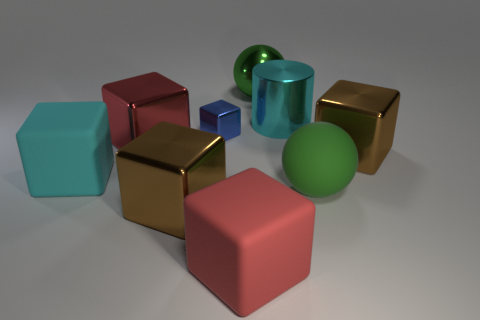There is a ball that is the same material as the large cyan cylinder; what is its color?
Ensure brevity in your answer.  Green. There is a cyan cube; does it have the same size as the red matte cube in front of the large cylinder?
Make the answer very short. Yes. The tiny thing has what shape?
Ensure brevity in your answer.  Cube. How many other things have the same color as the tiny thing?
Keep it short and to the point. 0. There is a tiny shiny object that is the same shape as the cyan matte thing; what color is it?
Keep it short and to the point. Blue. What number of spheres are behind the metallic block that is to the right of the small cube?
Give a very brief answer. 1. How many cubes are large red matte things or big red objects?
Give a very brief answer. 2. Are there any large red objects?
Provide a short and direct response. Yes. There is a blue object that is the same shape as the red rubber thing; what size is it?
Give a very brief answer. Small. There is a brown object that is in front of the brown cube that is right of the matte sphere; what shape is it?
Your answer should be compact. Cube. 